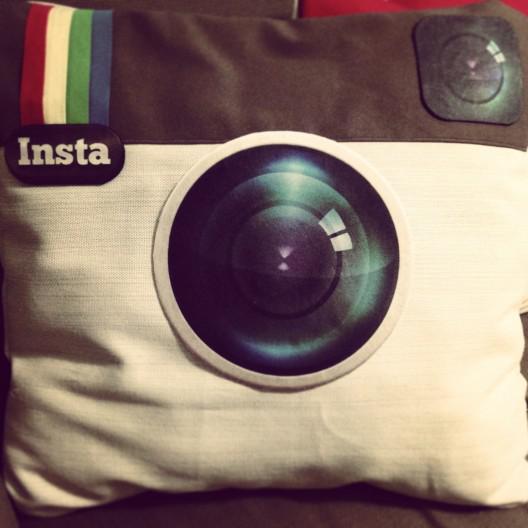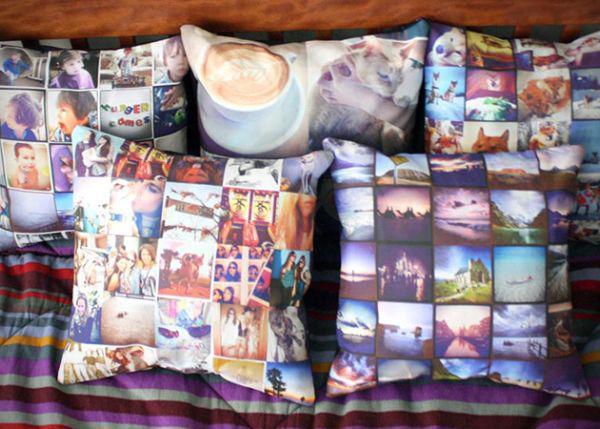The first image is the image on the left, the second image is the image on the right. Given the left and right images, does the statement "Each image includes a square pillow containing multiple rows of pictures, and in at least one image, the pictures on the pillow form a collage with no space between them." hold true? Answer yes or no. No. The first image is the image on the left, the second image is the image on the right. Given the left and right images, does the statement "At least one of the pillows is designed to look like the Instagram logo." hold true? Answer yes or no. Yes. 